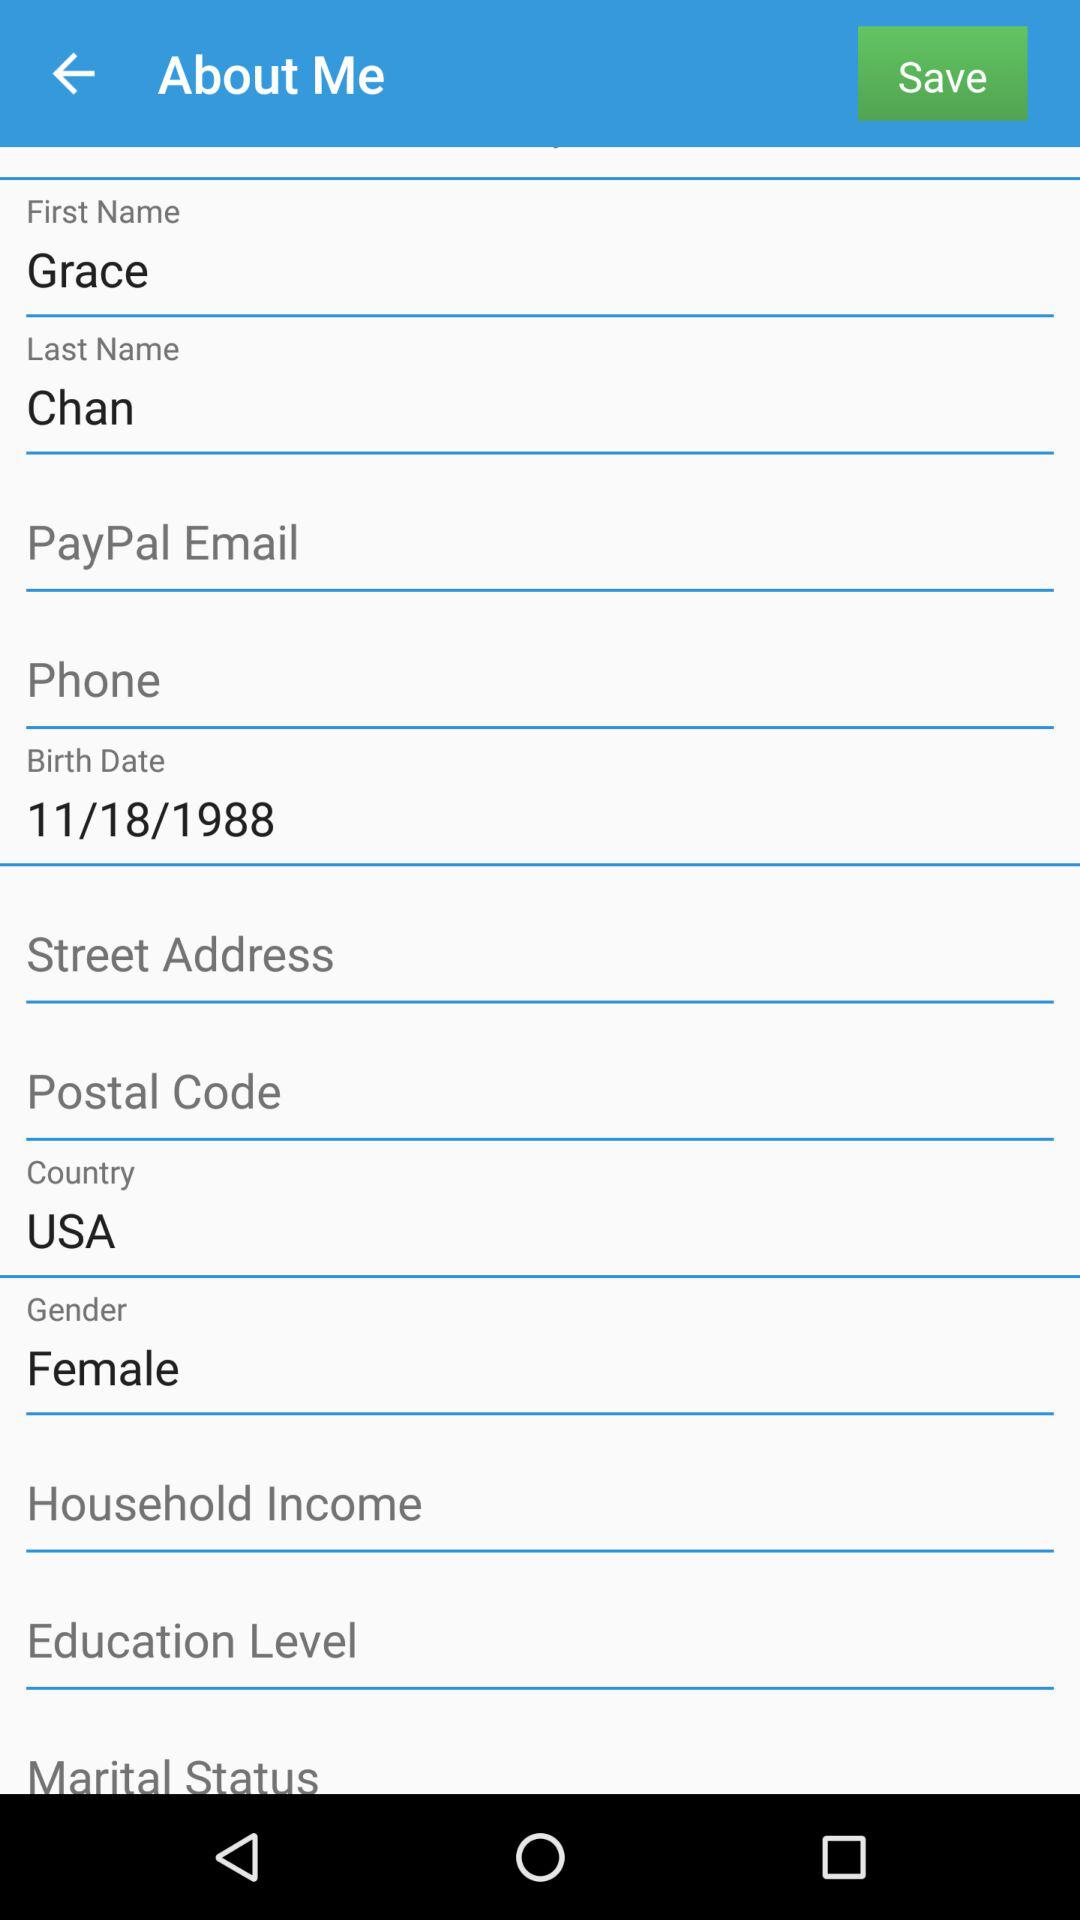What is the name of the country? The name of the country is the USA. 